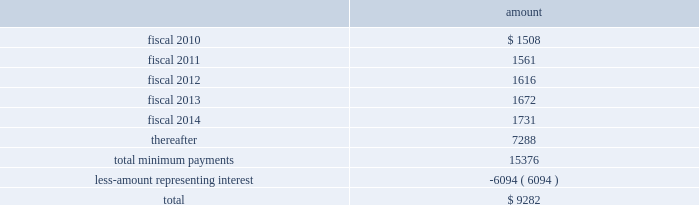Table of contents hologic , inc .
Notes to consolidated financial statements ( continued ) ( in thousands , except per share data ) location during fiscal 2009 .
The company was responsible for a significant portion of the construction costs and therefore was deemed , for accounting purposes , to be the owner of the building during the construction period , in accordance with asc 840 , leases , subsection 40-15-5 .
During the year ended september 27 , 2008 , the company recorded an additional $ 4400 in fair market value of the building , which was completed in fiscal 2008 .
This is in addition to the $ 3000 fair market value of the land and the $ 7700 fair market value related to the building constructed that cytyc had recorded as of october 22 , 2007 .
The company has recorded such fair market value within property and equipment on its consolidated balance sheets .
At september 26 , 2009 , the company has recorded $ 1508 in accrued expenses and $ 16329 in other long-term liabilities related to this obligation in the consolidated balance sheet .
The term of the lease is for a period of approximately ten years with the option to extend for two consecutive five-year terms .
The lease term commenced in may 2008 , at which time the company began transferring the company 2019s costa rican operations to this facility .
It is expected that this process will be complete by february 2009 .
At the completion of the construction period , the company reviewed the lease for potential sale-leaseback treatment in accordance with asc 840 , subsection 40 , sale-leaseback transactions ( formerly sfas no .
98 ( 201csfas 98 201d ) , accounting for leases : sale-leaseback transactions involving real estate , sales-type leases of real estate , definition of the lease term , and initial direct costs of direct financing leases 2014an amendment of financial accounting standards board ( 201cfasb 201d ) statements no .
13 , 66 , and 91 and a rescission of fasb statement no .
26 and technical bulletin no .
79-11 ) .
Based on its analysis , the company determined that the lease did not qualify for sale-leaseback treatment .
Therefore , the building , leasehold improvements and associated liabilities will remain on the company 2019s financial statements throughout the lease term , and the building and leasehold improvements will be depreciated on a straight line basis over their estimated useful lives of 35 years .
Future minimum lease payments , including principal and interest , under this lease were as follows at september 26 , 2009: .
In addition , as a result of the merger with cytyc , the company assumed the obligation to a non-cancelable lease agreement for a building with approximately 146000 square feet located in marlborough , massachusetts , to be principally used as an additional manufacturing facility .
In 2011 , the company will have an option to lease an additional 30000 square feet .
As part of the lease agreement , the lessor agreed to allow the company to make significant renovations to the facility to prepare the facility for the company 2019s manufacturing needs .
The company was responsible for a significant amount of the construction costs and therefore was deemed , for accounting purposes , to be the owner of the building during the construction period in accordance with asc 840-40-15-5 .
The $ 13200 fair market value of the facility is included within property and equipment , net on the consolidated balance sheet .
At september 26 , 2009 , the company has recorded $ 982 in accrued expenses and source : hologic inc , 10-k , november 24 , 2009 powered by morningstar ae document research 2120 the information contained herein may not be copied , adapted or distributed and is not warranted to be accurate , complete or timely .
The user assumes all risks for any damages or losses arising from any use of this information , except to the extent such damages or losses cannot be limited or excluded by applicable law .
Past financial performance is no guarantee of future results. .
What portion of the total future minimum lease payments is due in the next 12 months? 
Computations: (1508 / 15376)
Answer: 0.09807. Table of contents hologic , inc .
Notes to consolidated financial statements ( continued ) ( in thousands , except per share data ) location during fiscal 2009 .
The company was responsible for a significant portion of the construction costs and therefore was deemed , for accounting purposes , to be the owner of the building during the construction period , in accordance with asc 840 , leases , subsection 40-15-5 .
During the year ended september 27 , 2008 , the company recorded an additional $ 4400 in fair market value of the building , which was completed in fiscal 2008 .
This is in addition to the $ 3000 fair market value of the land and the $ 7700 fair market value related to the building constructed that cytyc had recorded as of october 22 , 2007 .
The company has recorded such fair market value within property and equipment on its consolidated balance sheets .
At september 26 , 2009 , the company has recorded $ 1508 in accrued expenses and $ 16329 in other long-term liabilities related to this obligation in the consolidated balance sheet .
The term of the lease is for a period of approximately ten years with the option to extend for two consecutive five-year terms .
The lease term commenced in may 2008 , at which time the company began transferring the company 2019s costa rican operations to this facility .
It is expected that this process will be complete by february 2009 .
At the completion of the construction period , the company reviewed the lease for potential sale-leaseback treatment in accordance with asc 840 , subsection 40 , sale-leaseback transactions ( formerly sfas no .
98 ( 201csfas 98 201d ) , accounting for leases : sale-leaseback transactions involving real estate , sales-type leases of real estate , definition of the lease term , and initial direct costs of direct financing leases 2014an amendment of financial accounting standards board ( 201cfasb 201d ) statements no .
13 , 66 , and 91 and a rescission of fasb statement no .
26 and technical bulletin no .
79-11 ) .
Based on its analysis , the company determined that the lease did not qualify for sale-leaseback treatment .
Therefore , the building , leasehold improvements and associated liabilities will remain on the company 2019s financial statements throughout the lease term , and the building and leasehold improvements will be depreciated on a straight line basis over their estimated useful lives of 35 years .
Future minimum lease payments , including principal and interest , under this lease were as follows at september 26 , 2009: .
In addition , as a result of the merger with cytyc , the company assumed the obligation to a non-cancelable lease agreement for a building with approximately 146000 square feet located in marlborough , massachusetts , to be principally used as an additional manufacturing facility .
In 2011 , the company will have an option to lease an additional 30000 square feet .
As part of the lease agreement , the lessor agreed to allow the company to make significant renovations to the facility to prepare the facility for the company 2019s manufacturing needs .
The company was responsible for a significant amount of the construction costs and therefore was deemed , for accounting purposes , to be the owner of the building during the construction period in accordance with asc 840-40-15-5 .
The $ 13200 fair market value of the facility is included within property and equipment , net on the consolidated balance sheet .
At september 26 , 2009 , the company has recorded $ 982 in accrued expenses and source : hologic inc , 10-k , november 24 , 2009 powered by morningstar ae document research 2120 the information contained herein may not be copied , adapted or distributed and is not warranted to be accurate , complete or timely .
The user assumes all risks for any damages or losses arising from any use of this information , except to the extent such damages or losses cannot be limited or excluded by applicable law .
Past financial performance is no guarantee of future results. .
What percentage of lease payments will be paid after 2014? 
Rationale: to find this answer one must divide the amount of lease payments after 2014 by the total amount of lease payments .
Computations: (7288 / 9282)
Answer: 0.78518. Table of contents hologic , inc .
Notes to consolidated financial statements ( continued ) ( in thousands , except per share data ) location during fiscal 2009 .
The company was responsible for a significant portion of the construction costs and therefore was deemed , for accounting purposes , to be the owner of the building during the construction period , in accordance with asc 840 , leases , subsection 40-15-5 .
During the year ended september 27 , 2008 , the company recorded an additional $ 4400 in fair market value of the building , which was completed in fiscal 2008 .
This is in addition to the $ 3000 fair market value of the land and the $ 7700 fair market value related to the building constructed that cytyc had recorded as of october 22 , 2007 .
The company has recorded such fair market value within property and equipment on its consolidated balance sheets .
At september 26 , 2009 , the company has recorded $ 1508 in accrued expenses and $ 16329 in other long-term liabilities related to this obligation in the consolidated balance sheet .
The term of the lease is for a period of approximately ten years with the option to extend for two consecutive five-year terms .
The lease term commenced in may 2008 , at which time the company began transferring the company 2019s costa rican operations to this facility .
It is expected that this process will be complete by february 2009 .
At the completion of the construction period , the company reviewed the lease for potential sale-leaseback treatment in accordance with asc 840 , subsection 40 , sale-leaseback transactions ( formerly sfas no .
98 ( 201csfas 98 201d ) , accounting for leases : sale-leaseback transactions involving real estate , sales-type leases of real estate , definition of the lease term , and initial direct costs of direct financing leases 2014an amendment of financial accounting standards board ( 201cfasb 201d ) statements no .
13 , 66 , and 91 and a rescission of fasb statement no .
26 and technical bulletin no .
79-11 ) .
Based on its analysis , the company determined that the lease did not qualify for sale-leaseback treatment .
Therefore , the building , leasehold improvements and associated liabilities will remain on the company 2019s financial statements throughout the lease term , and the building and leasehold improvements will be depreciated on a straight line basis over their estimated useful lives of 35 years .
Future minimum lease payments , including principal and interest , under this lease were as follows at september 26 , 2009: .
In addition , as a result of the merger with cytyc , the company assumed the obligation to a non-cancelable lease agreement for a building with approximately 146000 square feet located in marlborough , massachusetts , to be principally used as an additional manufacturing facility .
In 2011 , the company will have an option to lease an additional 30000 square feet .
As part of the lease agreement , the lessor agreed to allow the company to make significant renovations to the facility to prepare the facility for the company 2019s manufacturing needs .
The company was responsible for a significant amount of the construction costs and therefore was deemed , for accounting purposes , to be the owner of the building during the construction period in accordance with asc 840-40-15-5 .
The $ 13200 fair market value of the facility is included within property and equipment , net on the consolidated balance sheet .
At september 26 , 2009 , the company has recorded $ 982 in accrued expenses and source : hologic inc , 10-k , november 24 , 2009 powered by morningstar ae document research 2120 the information contained herein may not be copied , adapted or distributed and is not warranted to be accurate , complete or timely .
The user assumes all risks for any damages or losses arising from any use of this information , except to the extent such damages or losses cannot be limited or excluded by applicable law .
Past financial performance is no guarantee of future results. .
What was the total fair value building that cytyc had finished constructing in 2008 including the fair market value of the land? 
Rationale: to find the total fair value of the building one must added the fair market valuation of the building and land in 2007 and add the additional fair market valuation in 2008 .
Computations: (7700 + (3000 + 4400))
Answer: 15100.0. 